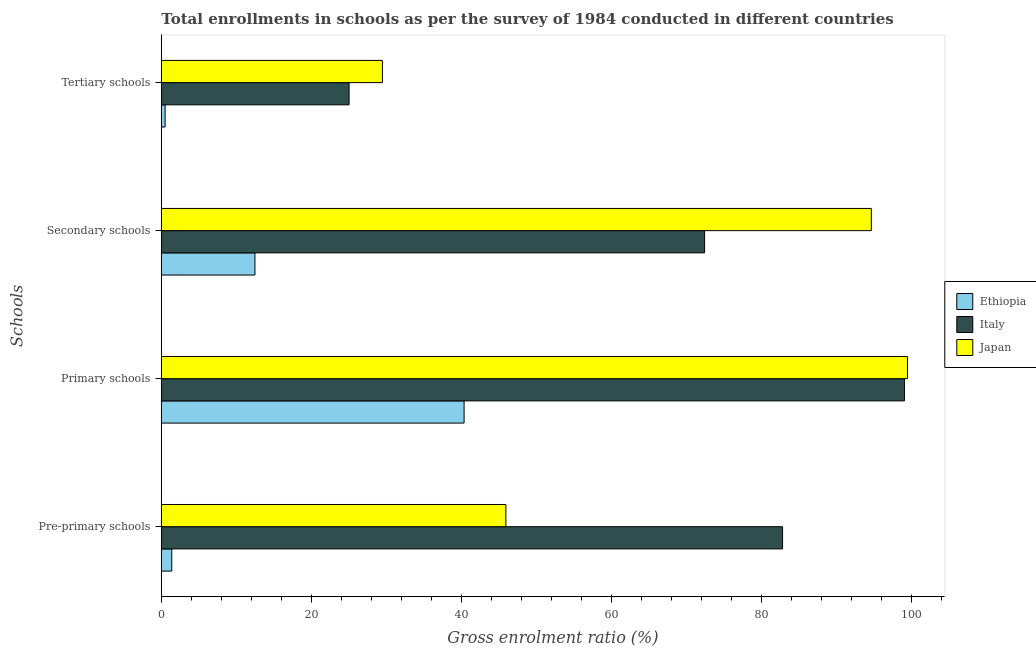How many groups of bars are there?
Your answer should be very brief. 4. Are the number of bars per tick equal to the number of legend labels?
Provide a short and direct response. Yes. How many bars are there on the 4th tick from the bottom?
Give a very brief answer. 3. What is the label of the 3rd group of bars from the top?
Your answer should be compact. Primary schools. What is the gross enrolment ratio in tertiary schools in Ethiopia?
Provide a short and direct response. 0.5. Across all countries, what is the maximum gross enrolment ratio in tertiary schools?
Make the answer very short. 29.49. Across all countries, what is the minimum gross enrolment ratio in tertiary schools?
Your response must be concise. 0.5. In which country was the gross enrolment ratio in tertiary schools minimum?
Provide a short and direct response. Ethiopia. What is the total gross enrolment ratio in secondary schools in the graph?
Give a very brief answer. 179.66. What is the difference between the gross enrolment ratio in secondary schools in Italy and that in Ethiopia?
Your answer should be compact. 59.98. What is the difference between the gross enrolment ratio in secondary schools in Italy and the gross enrolment ratio in primary schools in Japan?
Keep it short and to the point. -27.06. What is the average gross enrolment ratio in secondary schools per country?
Keep it short and to the point. 59.89. What is the difference between the gross enrolment ratio in secondary schools and gross enrolment ratio in primary schools in Ethiopia?
Keep it short and to the point. -27.9. What is the ratio of the gross enrolment ratio in pre-primary schools in Ethiopia to that in Italy?
Provide a short and direct response. 0.02. Is the gross enrolment ratio in primary schools in Japan less than that in Ethiopia?
Offer a terse response. No. What is the difference between the highest and the second highest gross enrolment ratio in tertiary schools?
Provide a succinct answer. 4.45. What is the difference between the highest and the lowest gross enrolment ratio in tertiary schools?
Ensure brevity in your answer.  28.99. In how many countries, is the gross enrolment ratio in tertiary schools greater than the average gross enrolment ratio in tertiary schools taken over all countries?
Keep it short and to the point. 2. Is it the case that in every country, the sum of the gross enrolment ratio in tertiary schools and gross enrolment ratio in pre-primary schools is greater than the sum of gross enrolment ratio in primary schools and gross enrolment ratio in secondary schools?
Offer a very short reply. No. What does the 1st bar from the top in Secondary schools represents?
Give a very brief answer. Japan. What does the 1st bar from the bottom in Tertiary schools represents?
Provide a succinct answer. Ethiopia. How many bars are there?
Give a very brief answer. 12. Are all the bars in the graph horizontal?
Your answer should be very brief. Yes. What is the difference between two consecutive major ticks on the X-axis?
Provide a short and direct response. 20. Does the graph contain any zero values?
Offer a very short reply. No. Does the graph contain grids?
Offer a very short reply. No. How many legend labels are there?
Keep it short and to the point. 3. How are the legend labels stacked?
Your answer should be very brief. Vertical. What is the title of the graph?
Provide a succinct answer. Total enrollments in schools as per the survey of 1984 conducted in different countries. What is the label or title of the X-axis?
Provide a succinct answer. Gross enrolment ratio (%). What is the label or title of the Y-axis?
Your answer should be very brief. Schools. What is the Gross enrolment ratio (%) of Ethiopia in Pre-primary schools?
Provide a succinct answer. 1.39. What is the Gross enrolment ratio (%) in Italy in Pre-primary schools?
Give a very brief answer. 82.86. What is the Gross enrolment ratio (%) of Japan in Pre-primary schools?
Your answer should be very brief. 45.96. What is the Gross enrolment ratio (%) in Ethiopia in Primary schools?
Provide a short and direct response. 40.38. What is the Gross enrolment ratio (%) in Italy in Primary schools?
Your answer should be very brief. 99.12. What is the Gross enrolment ratio (%) in Japan in Primary schools?
Your answer should be compact. 99.52. What is the Gross enrolment ratio (%) of Ethiopia in Secondary schools?
Give a very brief answer. 12.49. What is the Gross enrolment ratio (%) of Italy in Secondary schools?
Your answer should be very brief. 72.47. What is the Gross enrolment ratio (%) in Japan in Secondary schools?
Offer a terse response. 94.7. What is the Gross enrolment ratio (%) of Ethiopia in Tertiary schools?
Your response must be concise. 0.5. What is the Gross enrolment ratio (%) in Italy in Tertiary schools?
Your answer should be compact. 25.04. What is the Gross enrolment ratio (%) of Japan in Tertiary schools?
Your answer should be very brief. 29.49. Across all Schools, what is the maximum Gross enrolment ratio (%) in Ethiopia?
Provide a succinct answer. 40.38. Across all Schools, what is the maximum Gross enrolment ratio (%) in Italy?
Your answer should be compact. 99.12. Across all Schools, what is the maximum Gross enrolment ratio (%) of Japan?
Your response must be concise. 99.52. Across all Schools, what is the minimum Gross enrolment ratio (%) of Ethiopia?
Provide a succinct answer. 0.5. Across all Schools, what is the minimum Gross enrolment ratio (%) in Italy?
Provide a succinct answer. 25.04. Across all Schools, what is the minimum Gross enrolment ratio (%) of Japan?
Offer a very short reply. 29.49. What is the total Gross enrolment ratio (%) of Ethiopia in the graph?
Give a very brief answer. 54.77. What is the total Gross enrolment ratio (%) in Italy in the graph?
Your answer should be compact. 279.49. What is the total Gross enrolment ratio (%) of Japan in the graph?
Your response must be concise. 269.68. What is the difference between the Gross enrolment ratio (%) of Ethiopia in Pre-primary schools and that in Primary schools?
Offer a very short reply. -38.99. What is the difference between the Gross enrolment ratio (%) in Italy in Pre-primary schools and that in Primary schools?
Offer a very short reply. -16.25. What is the difference between the Gross enrolment ratio (%) of Japan in Pre-primary schools and that in Primary schools?
Make the answer very short. -53.57. What is the difference between the Gross enrolment ratio (%) in Ethiopia in Pre-primary schools and that in Secondary schools?
Give a very brief answer. -11.09. What is the difference between the Gross enrolment ratio (%) in Italy in Pre-primary schools and that in Secondary schools?
Make the answer very short. 10.4. What is the difference between the Gross enrolment ratio (%) of Japan in Pre-primary schools and that in Secondary schools?
Offer a terse response. -48.75. What is the difference between the Gross enrolment ratio (%) of Ethiopia in Pre-primary schools and that in Tertiary schools?
Your response must be concise. 0.89. What is the difference between the Gross enrolment ratio (%) in Italy in Pre-primary schools and that in Tertiary schools?
Your answer should be very brief. 57.82. What is the difference between the Gross enrolment ratio (%) of Japan in Pre-primary schools and that in Tertiary schools?
Ensure brevity in your answer.  16.46. What is the difference between the Gross enrolment ratio (%) in Ethiopia in Primary schools and that in Secondary schools?
Keep it short and to the point. 27.9. What is the difference between the Gross enrolment ratio (%) of Italy in Primary schools and that in Secondary schools?
Your answer should be compact. 26.65. What is the difference between the Gross enrolment ratio (%) in Japan in Primary schools and that in Secondary schools?
Provide a short and direct response. 4.82. What is the difference between the Gross enrolment ratio (%) of Ethiopia in Primary schools and that in Tertiary schools?
Provide a short and direct response. 39.88. What is the difference between the Gross enrolment ratio (%) of Italy in Primary schools and that in Tertiary schools?
Make the answer very short. 74.07. What is the difference between the Gross enrolment ratio (%) of Japan in Primary schools and that in Tertiary schools?
Provide a short and direct response. 70.03. What is the difference between the Gross enrolment ratio (%) in Ethiopia in Secondary schools and that in Tertiary schools?
Ensure brevity in your answer.  11.98. What is the difference between the Gross enrolment ratio (%) of Italy in Secondary schools and that in Tertiary schools?
Your answer should be compact. 47.42. What is the difference between the Gross enrolment ratio (%) in Japan in Secondary schools and that in Tertiary schools?
Ensure brevity in your answer.  65.21. What is the difference between the Gross enrolment ratio (%) in Ethiopia in Pre-primary schools and the Gross enrolment ratio (%) in Italy in Primary schools?
Ensure brevity in your answer.  -97.73. What is the difference between the Gross enrolment ratio (%) of Ethiopia in Pre-primary schools and the Gross enrolment ratio (%) of Japan in Primary schools?
Provide a succinct answer. -98.13. What is the difference between the Gross enrolment ratio (%) in Italy in Pre-primary schools and the Gross enrolment ratio (%) in Japan in Primary schools?
Give a very brief answer. -16.66. What is the difference between the Gross enrolment ratio (%) of Ethiopia in Pre-primary schools and the Gross enrolment ratio (%) of Italy in Secondary schools?
Keep it short and to the point. -71.07. What is the difference between the Gross enrolment ratio (%) of Ethiopia in Pre-primary schools and the Gross enrolment ratio (%) of Japan in Secondary schools?
Your answer should be compact. -93.31. What is the difference between the Gross enrolment ratio (%) in Italy in Pre-primary schools and the Gross enrolment ratio (%) in Japan in Secondary schools?
Provide a short and direct response. -11.84. What is the difference between the Gross enrolment ratio (%) of Ethiopia in Pre-primary schools and the Gross enrolment ratio (%) of Italy in Tertiary schools?
Keep it short and to the point. -23.65. What is the difference between the Gross enrolment ratio (%) of Ethiopia in Pre-primary schools and the Gross enrolment ratio (%) of Japan in Tertiary schools?
Offer a terse response. -28.1. What is the difference between the Gross enrolment ratio (%) in Italy in Pre-primary schools and the Gross enrolment ratio (%) in Japan in Tertiary schools?
Your response must be concise. 53.37. What is the difference between the Gross enrolment ratio (%) of Ethiopia in Primary schools and the Gross enrolment ratio (%) of Italy in Secondary schools?
Provide a succinct answer. -32.08. What is the difference between the Gross enrolment ratio (%) in Ethiopia in Primary schools and the Gross enrolment ratio (%) in Japan in Secondary schools?
Your answer should be compact. -54.32. What is the difference between the Gross enrolment ratio (%) in Italy in Primary schools and the Gross enrolment ratio (%) in Japan in Secondary schools?
Keep it short and to the point. 4.41. What is the difference between the Gross enrolment ratio (%) of Ethiopia in Primary schools and the Gross enrolment ratio (%) of Italy in Tertiary schools?
Provide a short and direct response. 15.34. What is the difference between the Gross enrolment ratio (%) in Ethiopia in Primary schools and the Gross enrolment ratio (%) in Japan in Tertiary schools?
Your answer should be compact. 10.89. What is the difference between the Gross enrolment ratio (%) in Italy in Primary schools and the Gross enrolment ratio (%) in Japan in Tertiary schools?
Your response must be concise. 69.63. What is the difference between the Gross enrolment ratio (%) of Ethiopia in Secondary schools and the Gross enrolment ratio (%) of Italy in Tertiary schools?
Give a very brief answer. -12.56. What is the difference between the Gross enrolment ratio (%) in Ethiopia in Secondary schools and the Gross enrolment ratio (%) in Japan in Tertiary schools?
Your answer should be compact. -17.01. What is the difference between the Gross enrolment ratio (%) of Italy in Secondary schools and the Gross enrolment ratio (%) of Japan in Tertiary schools?
Give a very brief answer. 42.97. What is the average Gross enrolment ratio (%) of Ethiopia per Schools?
Keep it short and to the point. 13.69. What is the average Gross enrolment ratio (%) in Italy per Schools?
Your response must be concise. 69.87. What is the average Gross enrolment ratio (%) in Japan per Schools?
Provide a short and direct response. 67.42. What is the difference between the Gross enrolment ratio (%) in Ethiopia and Gross enrolment ratio (%) in Italy in Pre-primary schools?
Offer a terse response. -81.47. What is the difference between the Gross enrolment ratio (%) of Ethiopia and Gross enrolment ratio (%) of Japan in Pre-primary schools?
Ensure brevity in your answer.  -44.56. What is the difference between the Gross enrolment ratio (%) of Italy and Gross enrolment ratio (%) of Japan in Pre-primary schools?
Provide a succinct answer. 36.91. What is the difference between the Gross enrolment ratio (%) in Ethiopia and Gross enrolment ratio (%) in Italy in Primary schools?
Offer a very short reply. -58.73. What is the difference between the Gross enrolment ratio (%) of Ethiopia and Gross enrolment ratio (%) of Japan in Primary schools?
Make the answer very short. -59.14. What is the difference between the Gross enrolment ratio (%) in Italy and Gross enrolment ratio (%) in Japan in Primary schools?
Your answer should be compact. -0.4. What is the difference between the Gross enrolment ratio (%) of Ethiopia and Gross enrolment ratio (%) of Italy in Secondary schools?
Offer a very short reply. -59.98. What is the difference between the Gross enrolment ratio (%) in Ethiopia and Gross enrolment ratio (%) in Japan in Secondary schools?
Keep it short and to the point. -82.22. What is the difference between the Gross enrolment ratio (%) of Italy and Gross enrolment ratio (%) of Japan in Secondary schools?
Ensure brevity in your answer.  -22.24. What is the difference between the Gross enrolment ratio (%) in Ethiopia and Gross enrolment ratio (%) in Italy in Tertiary schools?
Offer a terse response. -24.54. What is the difference between the Gross enrolment ratio (%) in Ethiopia and Gross enrolment ratio (%) in Japan in Tertiary schools?
Provide a succinct answer. -28.99. What is the difference between the Gross enrolment ratio (%) of Italy and Gross enrolment ratio (%) of Japan in Tertiary schools?
Offer a very short reply. -4.45. What is the ratio of the Gross enrolment ratio (%) of Ethiopia in Pre-primary schools to that in Primary schools?
Keep it short and to the point. 0.03. What is the ratio of the Gross enrolment ratio (%) in Italy in Pre-primary schools to that in Primary schools?
Make the answer very short. 0.84. What is the ratio of the Gross enrolment ratio (%) of Japan in Pre-primary schools to that in Primary schools?
Your answer should be compact. 0.46. What is the ratio of the Gross enrolment ratio (%) of Ethiopia in Pre-primary schools to that in Secondary schools?
Provide a succinct answer. 0.11. What is the ratio of the Gross enrolment ratio (%) of Italy in Pre-primary schools to that in Secondary schools?
Your response must be concise. 1.14. What is the ratio of the Gross enrolment ratio (%) in Japan in Pre-primary schools to that in Secondary schools?
Make the answer very short. 0.49. What is the ratio of the Gross enrolment ratio (%) of Ethiopia in Pre-primary schools to that in Tertiary schools?
Provide a succinct answer. 2.76. What is the ratio of the Gross enrolment ratio (%) of Italy in Pre-primary schools to that in Tertiary schools?
Your response must be concise. 3.31. What is the ratio of the Gross enrolment ratio (%) in Japan in Pre-primary schools to that in Tertiary schools?
Ensure brevity in your answer.  1.56. What is the ratio of the Gross enrolment ratio (%) in Ethiopia in Primary schools to that in Secondary schools?
Make the answer very short. 3.23. What is the ratio of the Gross enrolment ratio (%) in Italy in Primary schools to that in Secondary schools?
Offer a very short reply. 1.37. What is the ratio of the Gross enrolment ratio (%) of Japan in Primary schools to that in Secondary schools?
Offer a terse response. 1.05. What is the ratio of the Gross enrolment ratio (%) in Ethiopia in Primary schools to that in Tertiary schools?
Your answer should be very brief. 79.98. What is the ratio of the Gross enrolment ratio (%) of Italy in Primary schools to that in Tertiary schools?
Give a very brief answer. 3.96. What is the ratio of the Gross enrolment ratio (%) in Japan in Primary schools to that in Tertiary schools?
Keep it short and to the point. 3.37. What is the ratio of the Gross enrolment ratio (%) in Ethiopia in Secondary schools to that in Tertiary schools?
Keep it short and to the point. 24.73. What is the ratio of the Gross enrolment ratio (%) of Italy in Secondary schools to that in Tertiary schools?
Provide a short and direct response. 2.89. What is the ratio of the Gross enrolment ratio (%) of Japan in Secondary schools to that in Tertiary schools?
Keep it short and to the point. 3.21. What is the difference between the highest and the second highest Gross enrolment ratio (%) in Ethiopia?
Ensure brevity in your answer.  27.9. What is the difference between the highest and the second highest Gross enrolment ratio (%) of Italy?
Your answer should be very brief. 16.25. What is the difference between the highest and the second highest Gross enrolment ratio (%) of Japan?
Offer a terse response. 4.82. What is the difference between the highest and the lowest Gross enrolment ratio (%) in Ethiopia?
Ensure brevity in your answer.  39.88. What is the difference between the highest and the lowest Gross enrolment ratio (%) of Italy?
Give a very brief answer. 74.07. What is the difference between the highest and the lowest Gross enrolment ratio (%) of Japan?
Your response must be concise. 70.03. 